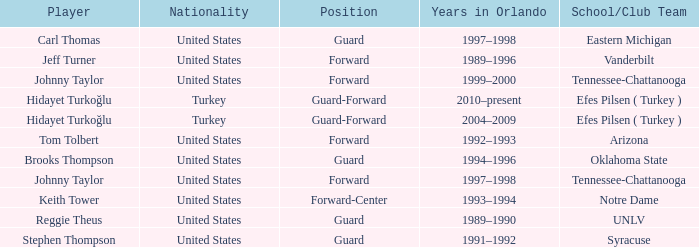What is the Position of the player from Vanderbilt? Forward. 